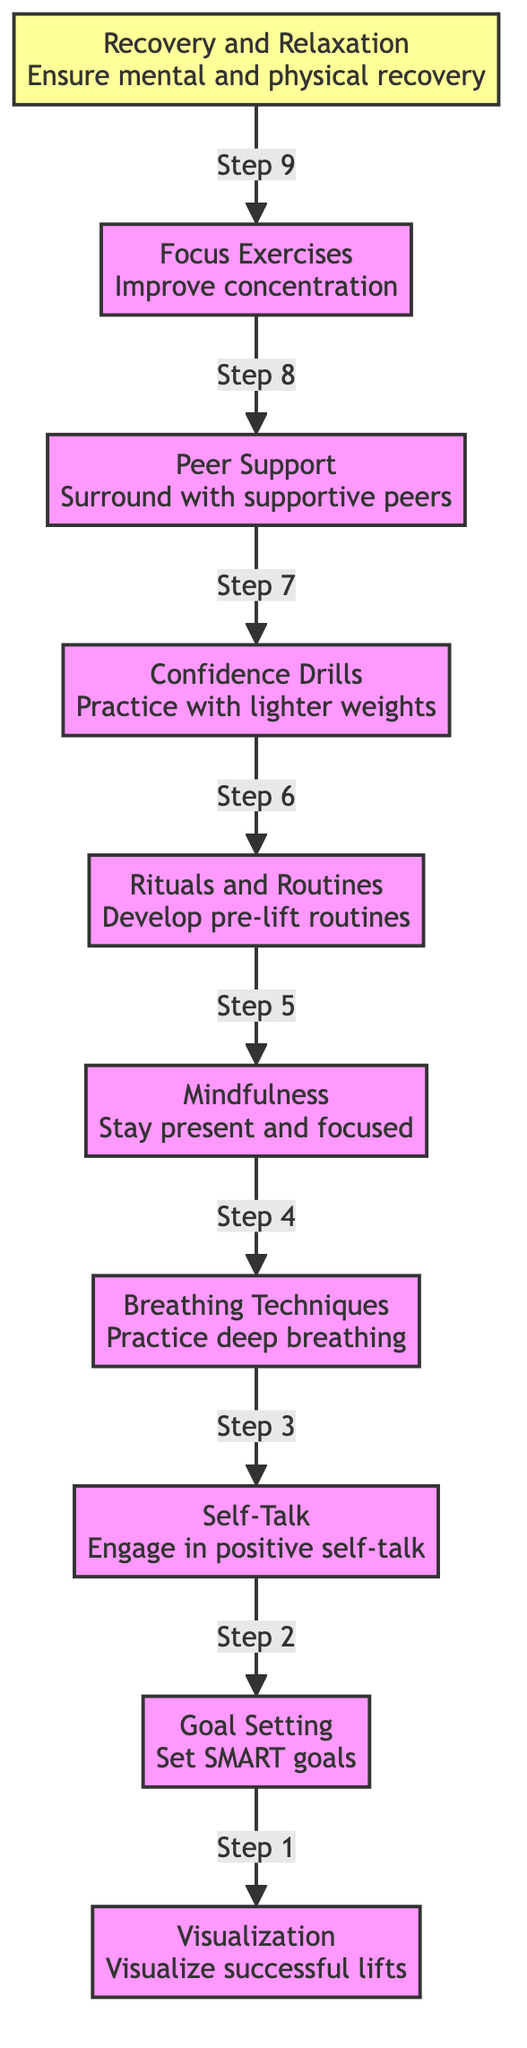What is the top-level technique in the diagram? The top-level technique is indicated at the highest point in the flow chart, which here is represented as the first node at the bottom before any connections are made. That node is "Recovery and Relaxation."
Answer: Recovery and Relaxation How many techniques are listed in the diagram? The diagram has a total of ten techniques outlined, each represented by a separate node. Counting these gives us the total number of techniques.
Answer: 10 What does the "Recovery and Relaxation" technique connect to? Starting from "Recovery and Relaxation," we proceed to the next node connected above it in the flow chart to determine what it transitions to. The next connection is to "Focus Exercises."
Answer: Focus Exercises Which technique is positioned directly before "Peer Support"? To find this, we check the nodes below "Peer Support" and identify which one gives a direct connection to it in the flow chart structure. The technique positioned directly before it is "Confidence Drills."
Answer: Confidence Drills What is the purpose of "Breathing Techniques"? By reviewing the node for "Breathing Techniques," we find the succinct description provided for that specific technique, outlining its purpose. It emphasizes the practice of deep breathing exercises to help with focus and anxiety.
Answer: Practice deep breathing Which technique is the last one in the flow of the diagram? The last technique can be identified by determining the highest level, which would be the final step in the sequence of mental conditioning techniques flowing upwards. This technique is "Visualization."
Answer: Visualization How many steps are there from "Visualization" to "Recovery and Relaxation"? To find the total number of steps, we simply count the nodes starting from "Visualization" all the way to "Recovery and Relaxation" while following the link connections, which includes each level until we reach the top. There are nine steps.
Answer: 9 Which techniques involve an aspect of mental focus? To answer this question, we review the nodes that specifically reference focus or concentration within their descriptions. The relevant techniques are "Breathing Techniques," "Mindfulness," and "Focus Exercises."
Answer: Breathing Techniques, Mindfulness, Focus Exercises What are the techniques that build confidence? We look at the nodes that specifically mention confidence in their descriptions, particularly "Self-Talk" and "Confidence Drills," to answer comprehensively.
Answer: Self-Talk, Confidence Drills 